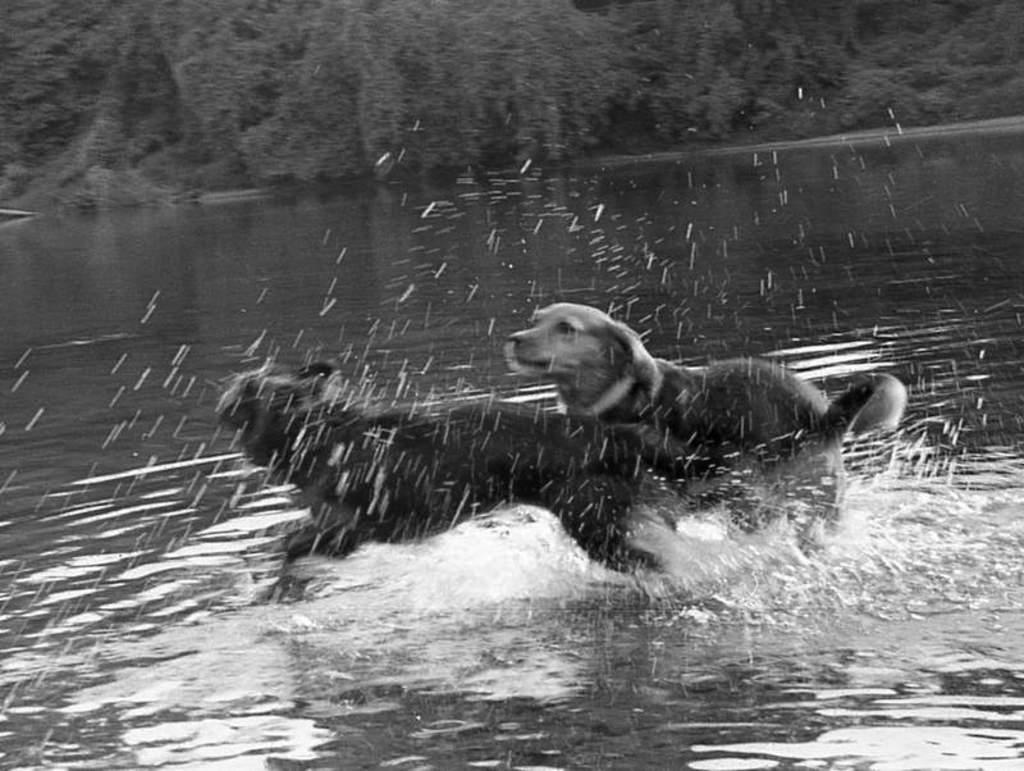What is the color scheme of the image? The image is black and white. How many dogs are present in the image? There are two dogs in the image. Where are the dogs located in the image? The dogs are in a water body. What can be seen in the background of the image? There is a group of trees visible in the background of the image. What type of guitar is the dog playing in the image? There is no guitar present in the image; it features two dogs in a water body. How many forks can be seen in the image? There are no forks present in the image. 